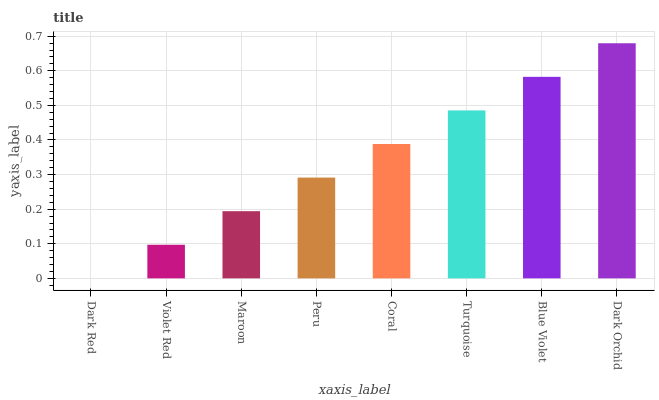Is Violet Red the minimum?
Answer yes or no. No. Is Violet Red the maximum?
Answer yes or no. No. Is Violet Red greater than Dark Red?
Answer yes or no. Yes. Is Dark Red less than Violet Red?
Answer yes or no. Yes. Is Dark Red greater than Violet Red?
Answer yes or no. No. Is Violet Red less than Dark Red?
Answer yes or no. No. Is Coral the high median?
Answer yes or no. Yes. Is Peru the low median?
Answer yes or no. Yes. Is Maroon the high median?
Answer yes or no. No. Is Maroon the low median?
Answer yes or no. No. 